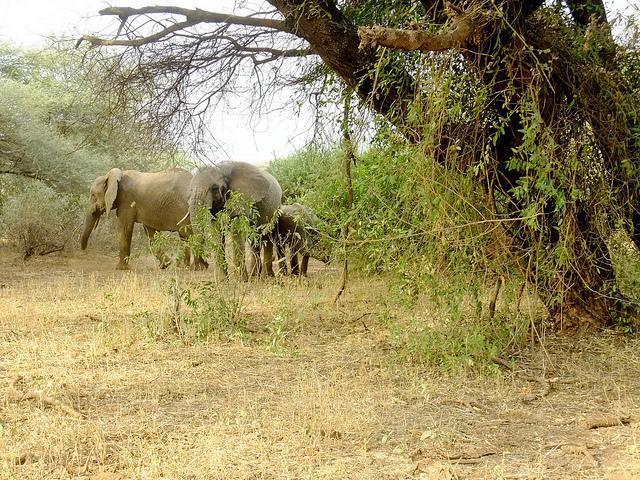How many elephants are there?
Give a very brief answer. 3. How many elephants can be seen?
Give a very brief answer. 3. 